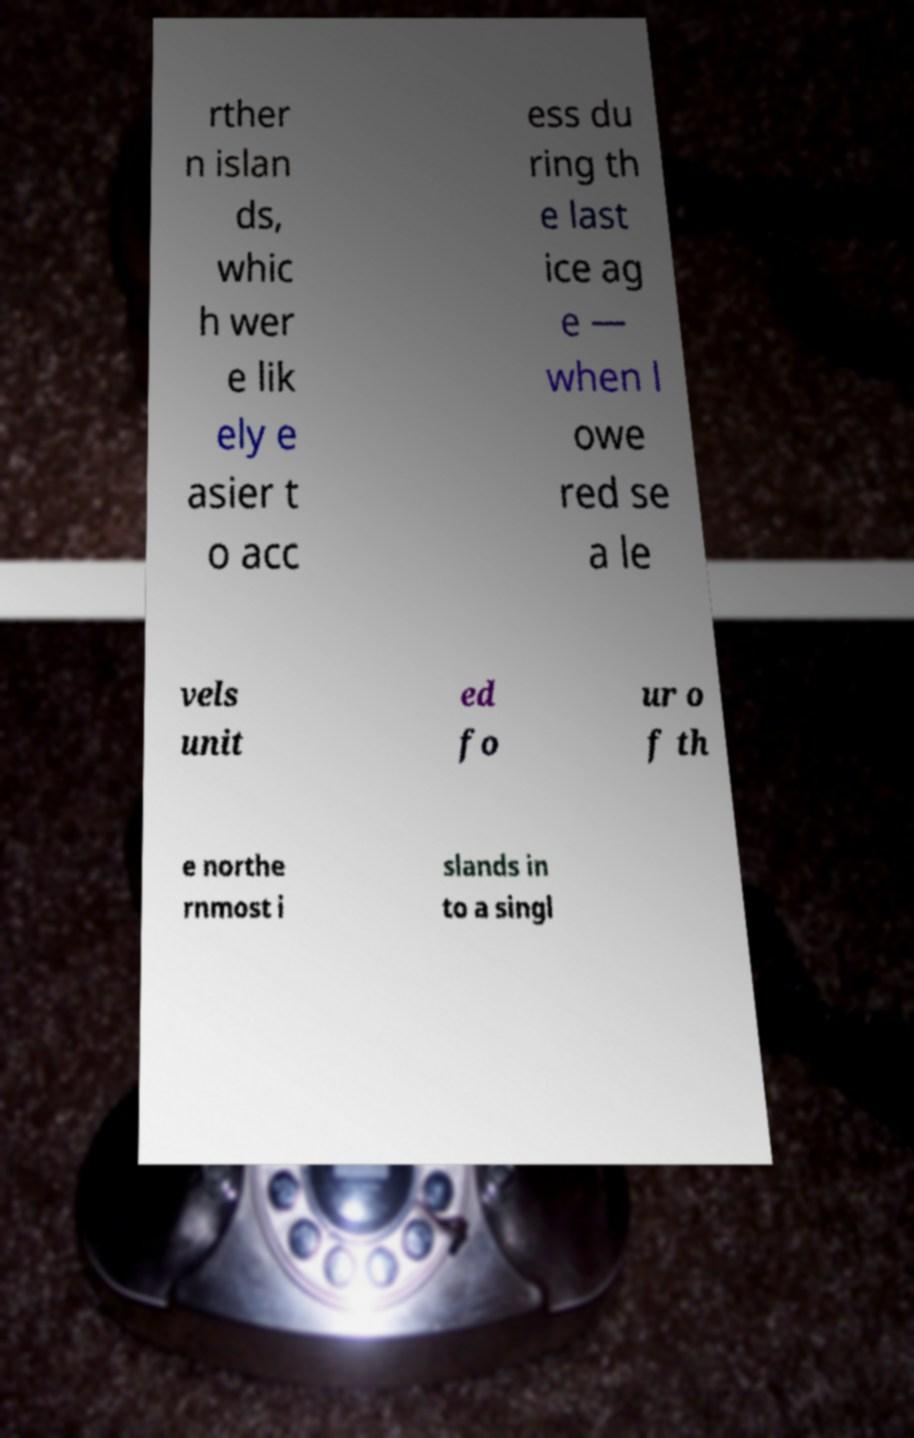Could you assist in decoding the text presented in this image and type it out clearly? rther n islan ds, whic h wer e lik ely e asier t o acc ess du ring th e last ice ag e — when l owe red se a le vels unit ed fo ur o f th e northe rnmost i slands in to a singl 